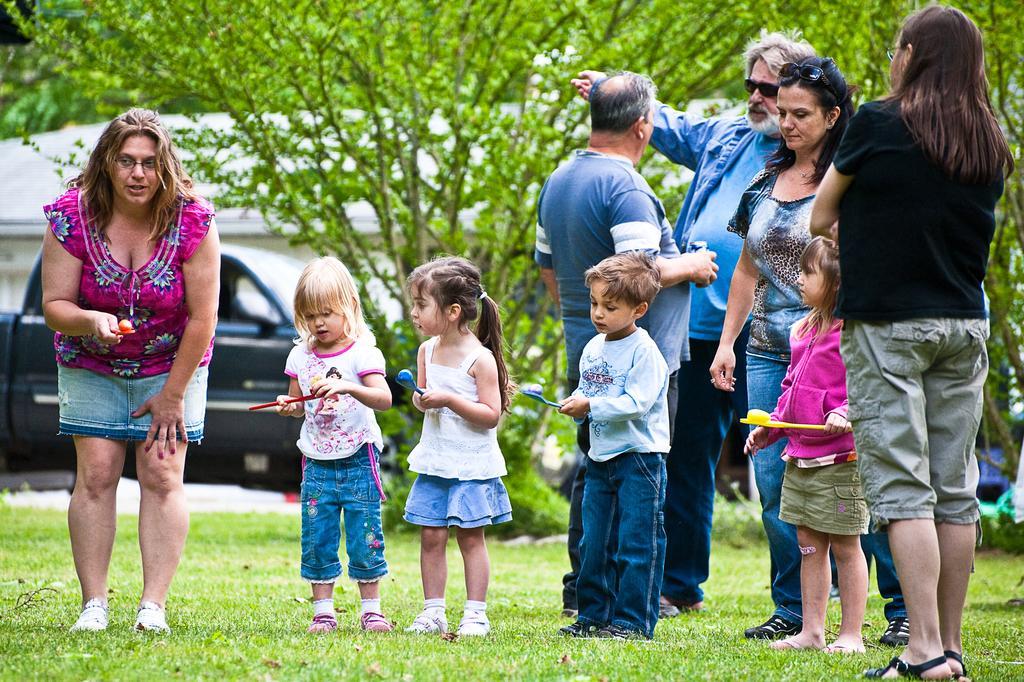Can you describe this image briefly? In this image we can see a few people standing, among them some are holding the objects, there are some trees, grass, vehicle and a house. 